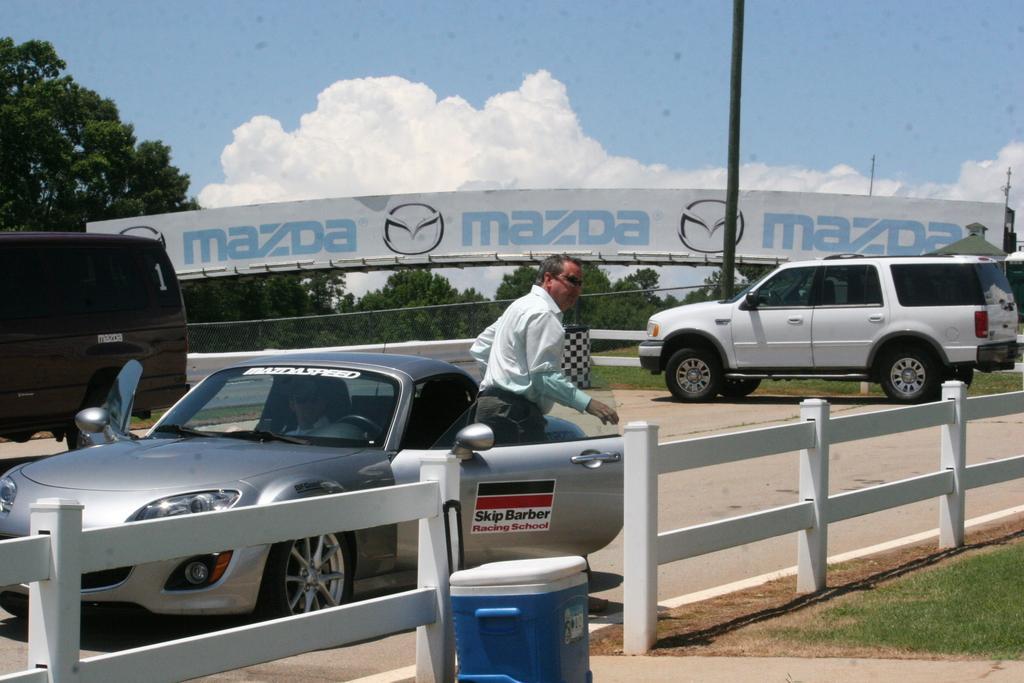Can you describe this image briefly? There is a person getting down from a car, which is on the road, on which there are other vehicles, near a white color fencing, which is near a blue color dustbin. On the right side, there is a grass on the ground. In the background, there is a white color hoarding, there are trees and clouds in the blue sky. 